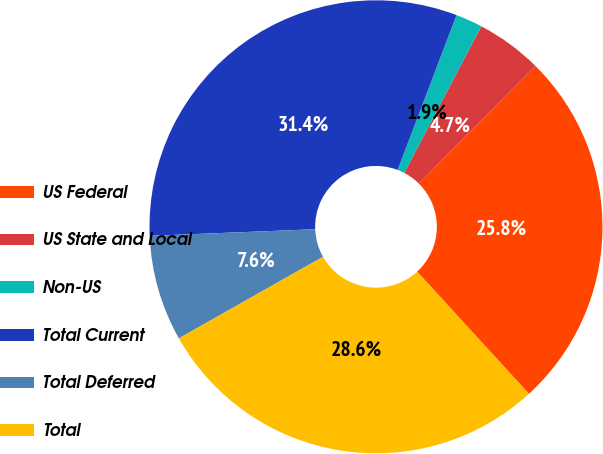Convert chart. <chart><loc_0><loc_0><loc_500><loc_500><pie_chart><fcel>US Federal<fcel>US State and Local<fcel>Non-US<fcel>Total Current<fcel>Total Deferred<fcel>Total<nl><fcel>25.78%<fcel>4.73%<fcel>1.91%<fcel>31.42%<fcel>7.56%<fcel>28.6%<nl></chart> 